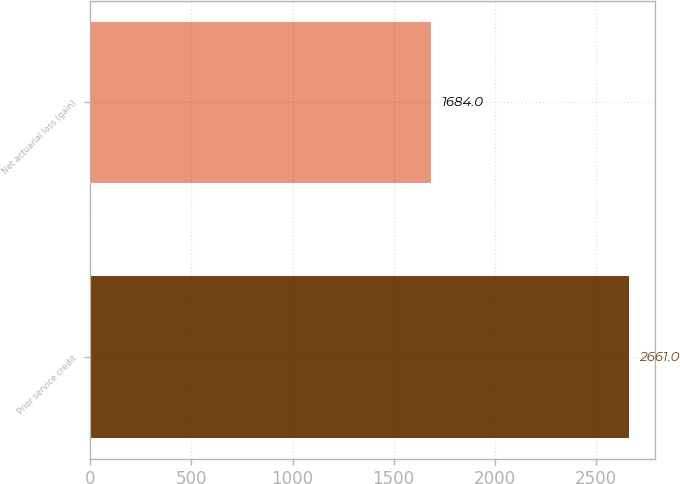Convert chart. <chart><loc_0><loc_0><loc_500><loc_500><bar_chart><fcel>Prior service credit<fcel>Net actuarial loss (gain)<nl><fcel>2661<fcel>1684<nl></chart> 